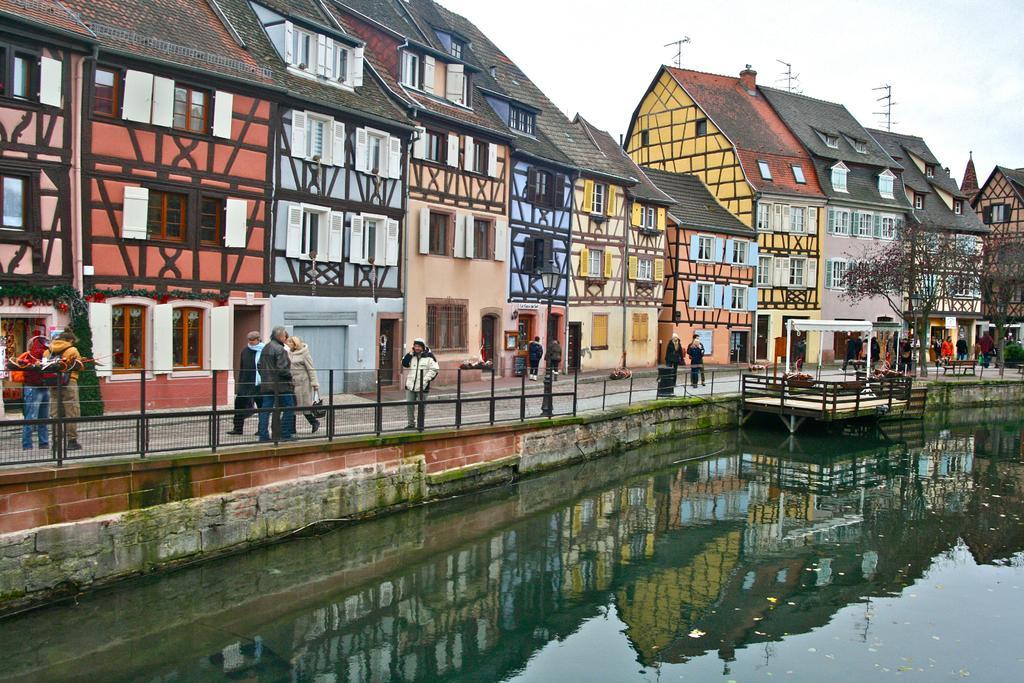Could you give a brief overview of what you see in this image? In this picture we can observe number of buildings which were in number of colors. We can observe blue, red, pink and cream colors. There is a path in front of these buildings. In this path there are some people walking and standing. There is a railing. We can observe water and trees. In the background there is a sky. 